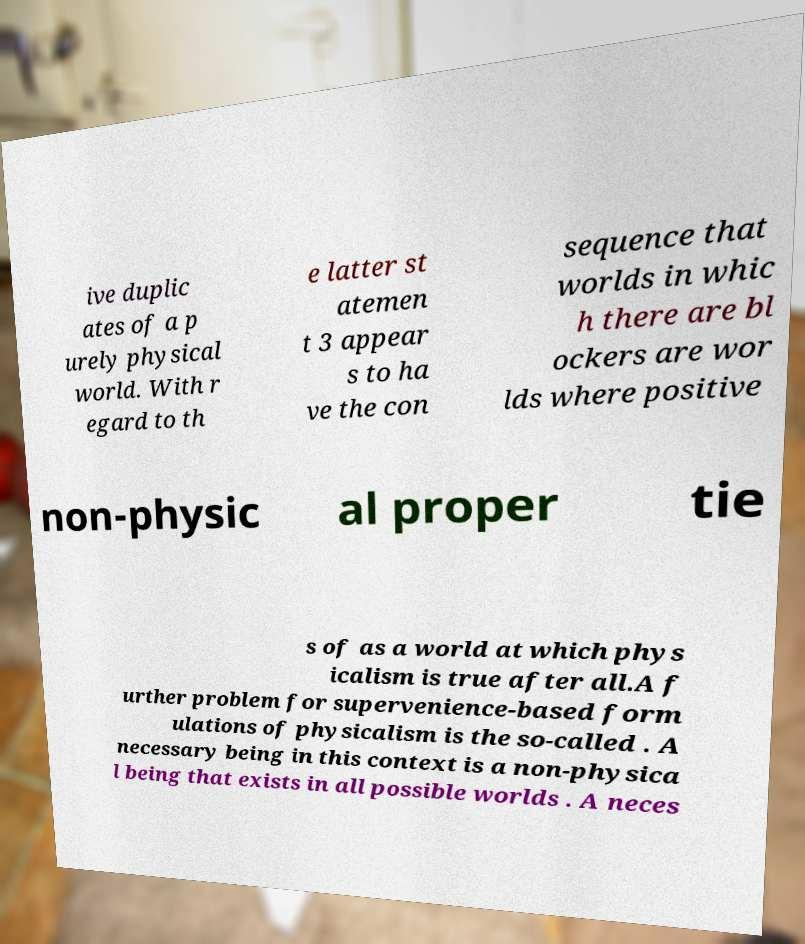Could you extract and type out the text from this image? ive duplic ates of a p urely physical world. With r egard to th e latter st atemen t 3 appear s to ha ve the con sequence that worlds in whic h there are bl ockers are wor lds where positive non-physic al proper tie s of as a world at which phys icalism is true after all.A f urther problem for supervenience-based form ulations of physicalism is the so-called . A necessary being in this context is a non-physica l being that exists in all possible worlds . A neces 